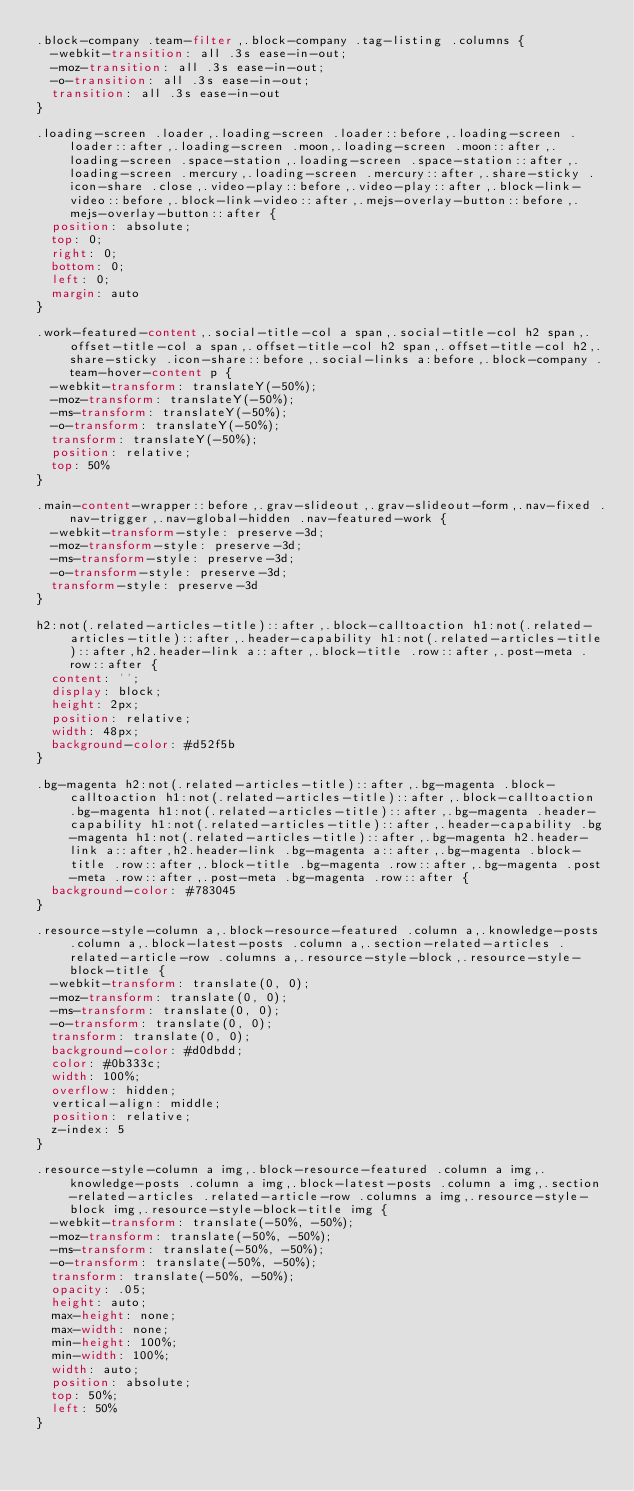Convert code to text. <code><loc_0><loc_0><loc_500><loc_500><_CSS_>.block-company .team-filter,.block-company .tag-listing .columns {
	-webkit-transition: all .3s ease-in-out;
	-moz-transition: all .3s ease-in-out;
	-o-transition: all .3s ease-in-out;
	transition: all .3s ease-in-out
}

.loading-screen .loader,.loading-screen .loader::before,.loading-screen .loader::after,.loading-screen .moon,.loading-screen .moon::after,.loading-screen .space-station,.loading-screen .space-station::after,.loading-screen .mercury,.loading-screen .mercury::after,.share-sticky .icon-share .close,.video-play::before,.video-play::after,.block-link-video::before,.block-link-video::after,.mejs-overlay-button::before,.mejs-overlay-button::after {
	position: absolute;
	top: 0;
	right: 0;
	bottom: 0;
	left: 0;
	margin: auto
}

.work-featured-content,.social-title-col a span,.social-title-col h2 span,.offset-title-col a span,.offset-title-col h2 span,.offset-title-col h2,.share-sticky .icon-share::before,.social-links a:before,.block-company .team-hover-content p {
	-webkit-transform: translateY(-50%);
	-moz-transform: translateY(-50%);
	-ms-transform: translateY(-50%);
	-o-transform: translateY(-50%);
	transform: translateY(-50%);
	position: relative;
	top: 50%
}

.main-content-wrapper::before,.grav-slideout,.grav-slideout-form,.nav-fixed .nav-trigger,.nav-global-hidden .nav-featured-work {
	-webkit-transform-style: preserve-3d;
	-moz-transform-style: preserve-3d;
	-ms-transform-style: preserve-3d;
	-o-transform-style: preserve-3d;
	transform-style: preserve-3d
}

h2:not(.related-articles-title)::after,.block-calltoaction h1:not(.related-articles-title)::after,.header-capability h1:not(.related-articles-title)::after,h2.header-link a::after,.block-title .row::after,.post-meta .row::after {
	content: '';
	display: block;
	height: 2px;
	position: relative;
	width: 48px;
	background-color: #d52f5b
}

.bg-magenta h2:not(.related-articles-title)::after,.bg-magenta .block-calltoaction h1:not(.related-articles-title)::after,.block-calltoaction .bg-magenta h1:not(.related-articles-title)::after,.bg-magenta .header-capability h1:not(.related-articles-title)::after,.header-capability .bg-magenta h1:not(.related-articles-title)::after,.bg-magenta h2.header-link a::after,h2.header-link .bg-magenta a::after,.bg-magenta .block-title .row::after,.block-title .bg-magenta .row::after,.bg-magenta .post-meta .row::after,.post-meta .bg-magenta .row::after {
	background-color: #783045
}

.resource-style-column a,.block-resource-featured .column a,.knowledge-posts .column a,.block-latest-posts .column a,.section-related-articles .related-article-row .columns a,.resource-style-block,.resource-style-block-title {
	-webkit-transform: translate(0, 0);
	-moz-transform: translate(0, 0);
	-ms-transform: translate(0, 0);
	-o-transform: translate(0, 0);
	transform: translate(0, 0);
	background-color: #d0dbdd;
	color: #0b333c;
	width: 100%;
	overflow: hidden;
	vertical-align: middle;
	position: relative;
	z-index: 5
}

.resource-style-column a img,.block-resource-featured .column a img,.knowledge-posts .column a img,.block-latest-posts .column a img,.section-related-articles .related-article-row .columns a img,.resource-style-block img,.resource-style-block-title img {
	-webkit-transform: translate(-50%, -50%);
	-moz-transform: translate(-50%, -50%);
	-ms-transform: translate(-50%, -50%);
	-o-transform: translate(-50%, -50%);
	transform: translate(-50%, -50%);
	opacity: .05;
	height: auto;
	max-height: none;
	max-width: none;
	min-height: 100%;
	min-width: 100%;
	width: auto;
	position: absolute;
	top: 50%;
	left: 50%
}
</code> 